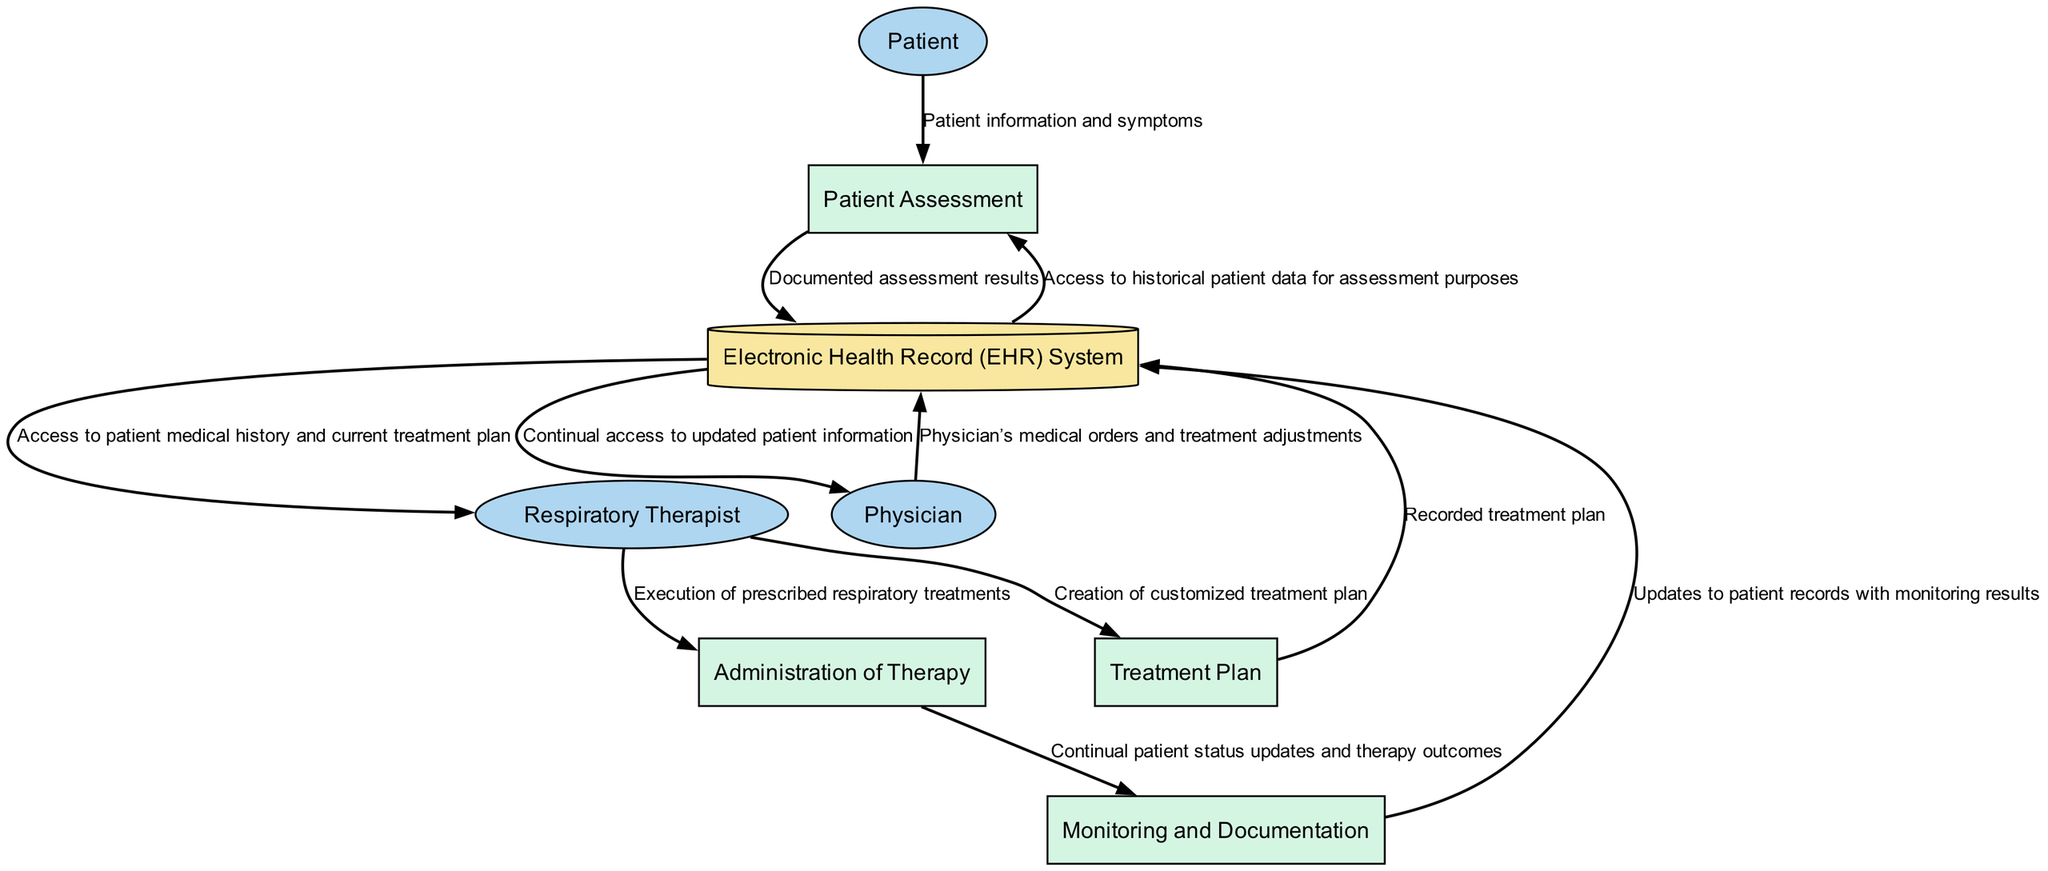What is the initial process involving the patient? The initial process that involves the patient is the "Patient Assessment." This process takes patient information and symptoms as input to evaluate their respiratory condition.
Answer: Patient Assessment How many external entities are present in the diagram? There are three external entities in the diagram: Patient, Respiratory Therapist, and Physician. These entities represent individuals responsible for processes in the workflow.
Answer: Three What data does the "Patient Assessment" send to the "Electronic Health Record (EHR) System"? The "Patient Assessment" sends "Documented assessment results" to the "Electronic Health Record (EHR) System" as part of the workflow, documenting the outcome of the assessment.
Answer: Documented assessment results What is a crucial document created in the "Treatment Plan" process? A crucial document created in the "Treatment Plan" process is the "Customized treatment plan," which is developed by the Respiratory Therapist tailored for the specific needs of the patient.
Answer: Customized treatment plan Which process directly follows the "Administration of Therapy"? The process that directly follows "Administration of Therapy" is "Monitoring and Documentation." This step ensures ongoing tracking and recording of the patient's therapy outcomes.
Answer: Monitoring and Documentation What does the "Monitoring and Documentation" process update in the EHR? The "Monitoring and Documentation" process updates the "Electronic Health Record (EHR) System" with "Monitoring results," which includes continuous status updates and therapy outcomes for the patient.
Answer: Monitoring results Which entity provides medical orders to the EHR System? The entity that provides medical orders to the "Electronic Health Record (EHR) System" is the "Physician." This interaction ensures that the latest treatment adjustments are documented and accessible.
Answer: Physician What flow of data occurs from the "EHR System" to the "Patient Assessment"? The flow of data from the "Electronic Health Record (EHR) System" to the "Patient Assessment" provides "Access to historical patient data for assessment purposes," helping to inform the assessment process.
Answer: Access to historical patient data for assessment purposes What type of diagram is shown? The type of diagram shown is a "Data Flow Diagram," which visually represents the way information flows between various entities and processes in the system regarding respiratory therapy workflow.
Answer: Data Flow Diagram 